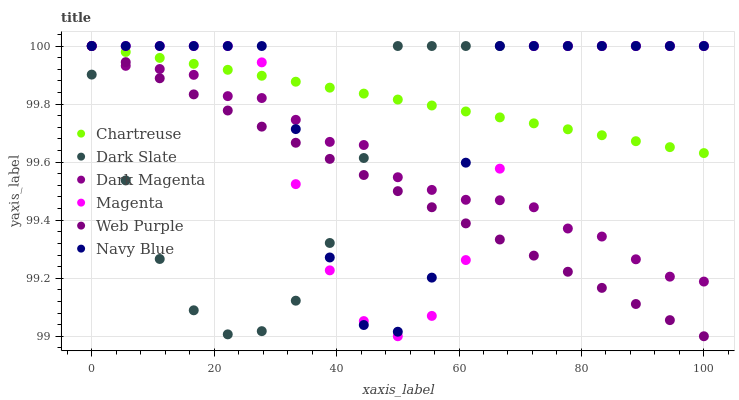Does Web Purple have the minimum area under the curve?
Answer yes or no. Yes. Does Chartreuse have the maximum area under the curve?
Answer yes or no. Yes. Does Navy Blue have the minimum area under the curve?
Answer yes or no. No. Does Navy Blue have the maximum area under the curve?
Answer yes or no. No. Is Web Purple the smoothest?
Answer yes or no. Yes. Is Navy Blue the roughest?
Answer yes or no. Yes. Is Navy Blue the smoothest?
Answer yes or no. No. Is Web Purple the roughest?
Answer yes or no. No. Does Magenta have the lowest value?
Answer yes or no. Yes. Does Navy Blue have the lowest value?
Answer yes or no. No. Does Magenta have the highest value?
Answer yes or no. Yes. Does Navy Blue intersect Magenta?
Answer yes or no. Yes. Is Navy Blue less than Magenta?
Answer yes or no. No. Is Navy Blue greater than Magenta?
Answer yes or no. No. 